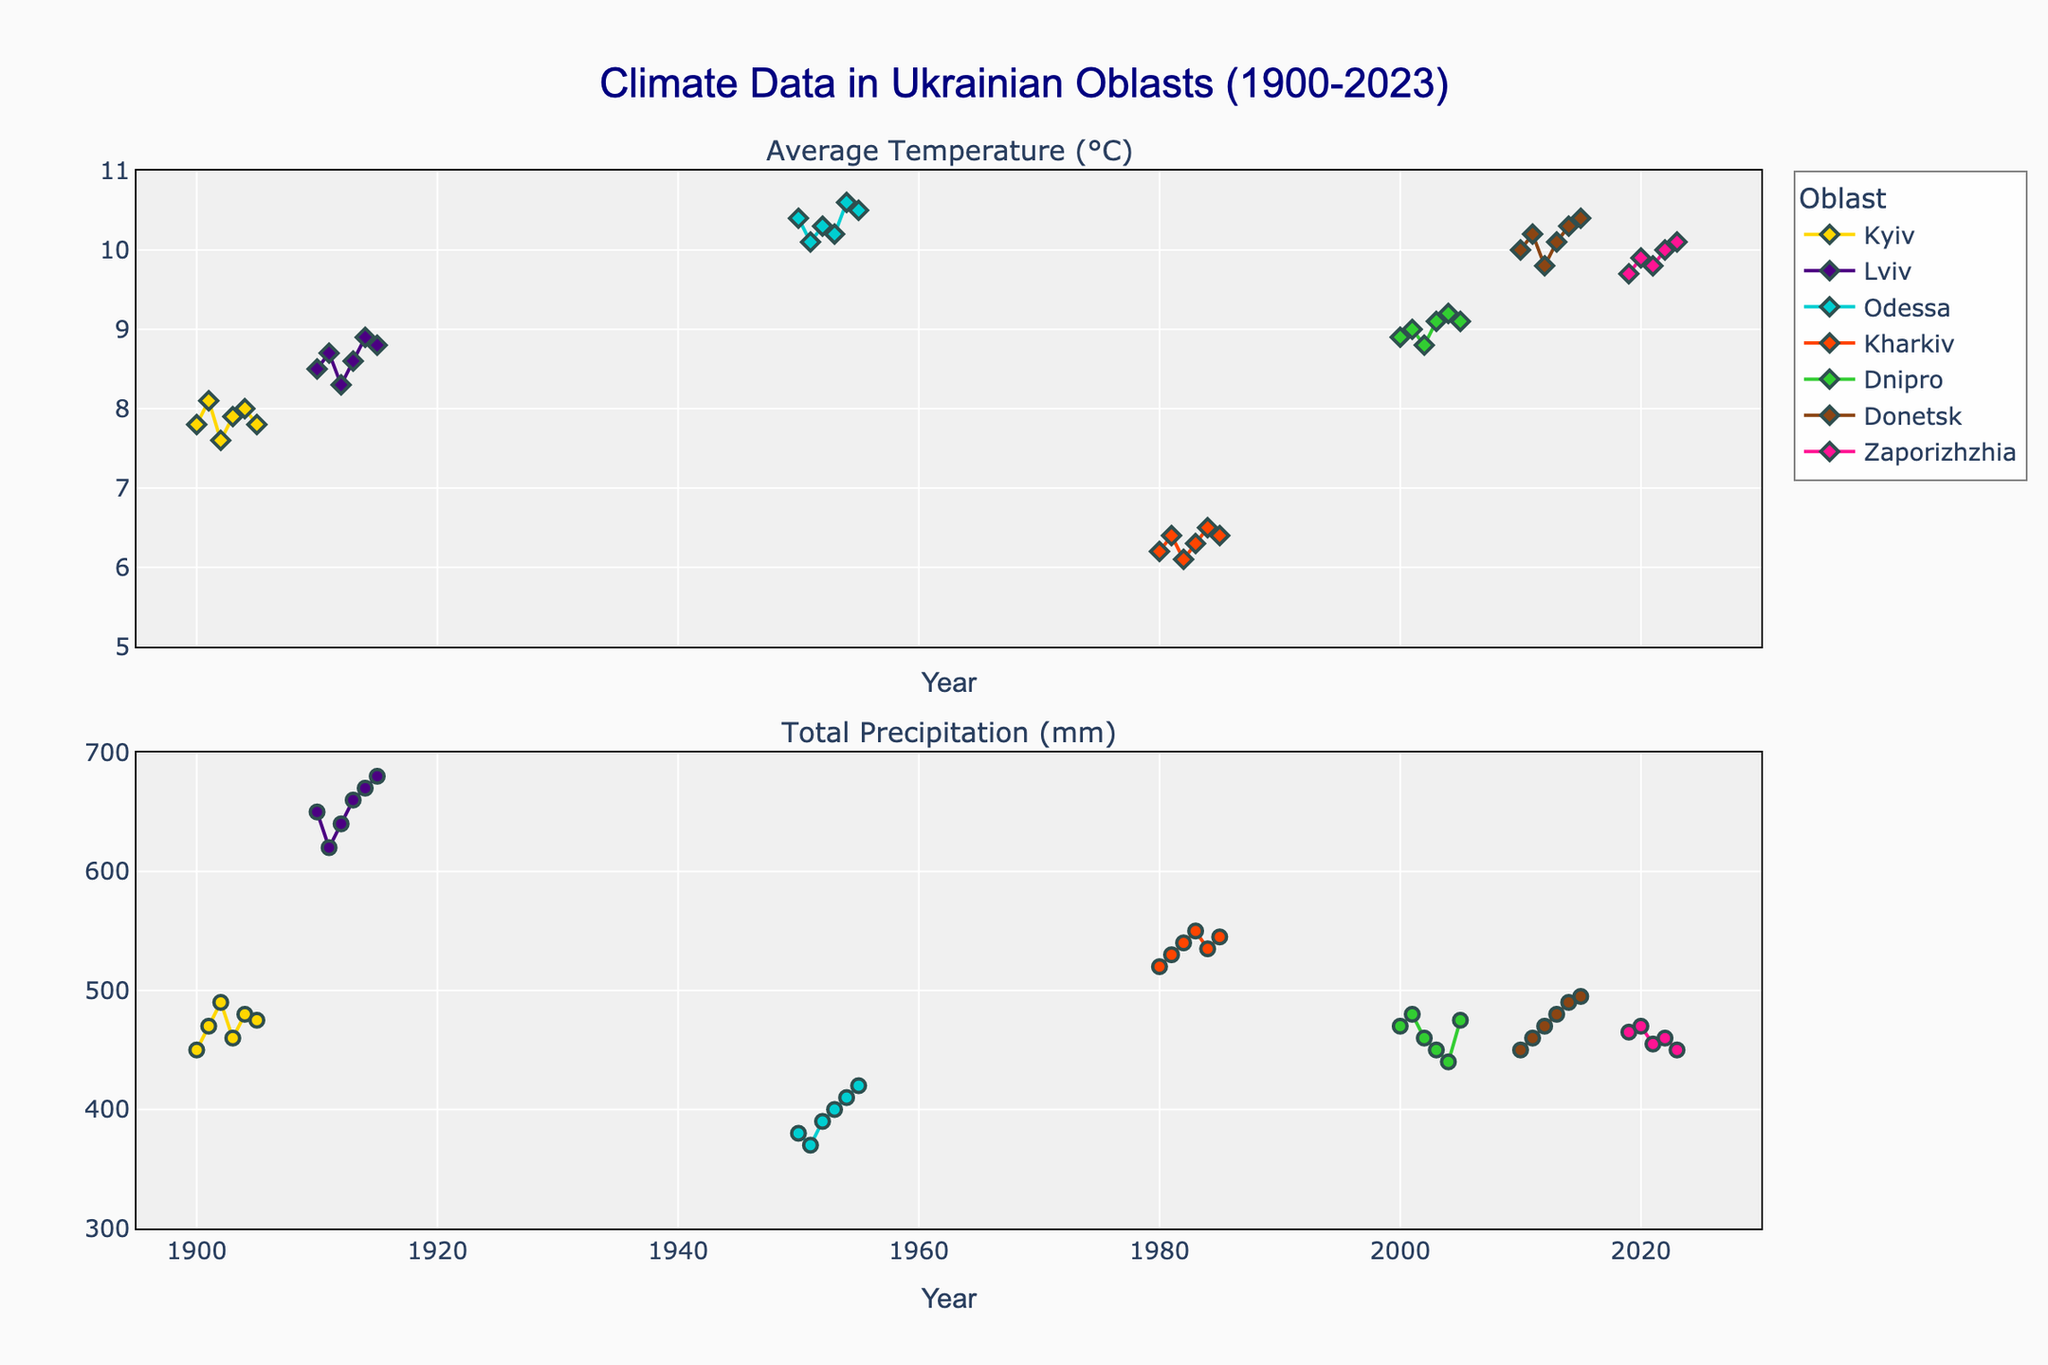Which oblast has the highest average temperature in the dataset? By looking at the first subplot showing average temperatures for various oblasts from 1900 to 2023, Odessa consistently shows the highest average temperatures, reaching up to about 10.6°C in 1954.
Answer: Odessa What is the range of years covered in the dataset? The x-axis scale of the plot shows data points starting from 1900 to 2023 for the various Ukrainian oblasts graphed.
Answer: 1900 to 2023 How does the average temperature trend of Kyiv from 1900 to 1905 compare to that of Lviv from 1910 to 1915? Kyiv’s average temperature trends between 7.6°C and 8.1°C from 1900 to 1905. Lviv shows a slightly higher average temperature trend between 8.3°C and 8.9°C from 1910 to 1915.
Answer: Lviv’s average temperature trend is higher Which oblast has the greatest range in total precipitation over the years covered? To determine the range, we need to look at the maximum and minimum total precipitation values for each oblast. Lviv ranges from 620 mm to 680 mm, giving a range of 60 mm, which is the largest compared to other oblasts.
Answer: Lviv What was the average temperature difference between Donetsk and Zaporizhzhia in 2020? In 2020, Donetsk had an average temperature of about 10.2°C, whereas Zaporizhzhia had an average temperature of 9.9°C. The difference is 10.2°C - 9.9°C.
Answer: 0.3°C Describe the trend of average temperatures in Dnipro from 2000 to 2005. The average temperature in Dnipro showed an overall increasing trend from 2000 (8.9°C) to 2005 (9.1°C), peaking in 2004 with 9.2°C before a slight dip in 2005.
Answer: Increasing trend Which oblast had the highest total precipitation in any given year, and what was the value? The second subplot, showing total precipitation, highlights that Lviv in 1915 had the highest total precipitation value at about 680 mm.
Answer: Lviv, 680 mm Can you identify any notable weather pattern shifts in Kharkiv between 1980 and 1985 in terms of precipitation? In Kharkiv, total precipitation increased from 520 mm in 1980 to 550 mm in 1983, then slightly decreased to 545 mm in 1985, indicating a rising and then stabilizing precipitation pattern.
Answer: Rising and stabilizing How do the average temperatures of Kharkiv in 1980 and Kyiv in 1900 compare? Observing the first subplot, the average temperature of Kharkiv in 1980 was 6.2°C, whereas for Kyiv in 1900, it was 7.8°C.
Answer: Kyiv had a higher temperature 